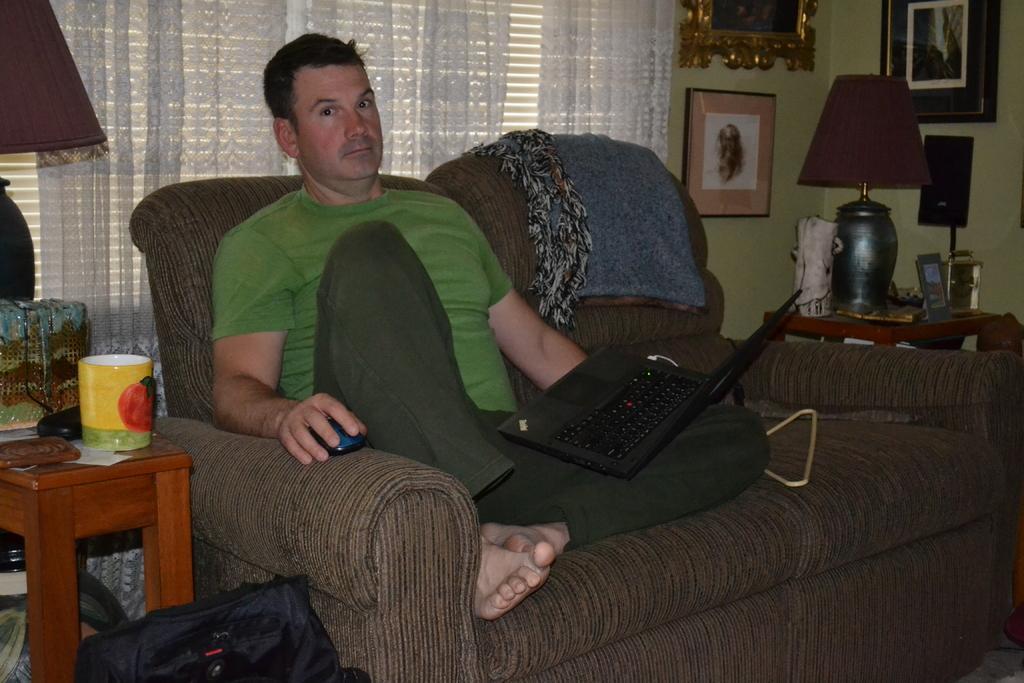In one or two sentences, can you explain what this image depicts? In this image I can see a man is sitting on a sofa and he is holding a mouse and a laptop. In the background I can see a lamp, a mug and few frames on these walls. I can also see a bag and one more lamp over here. 